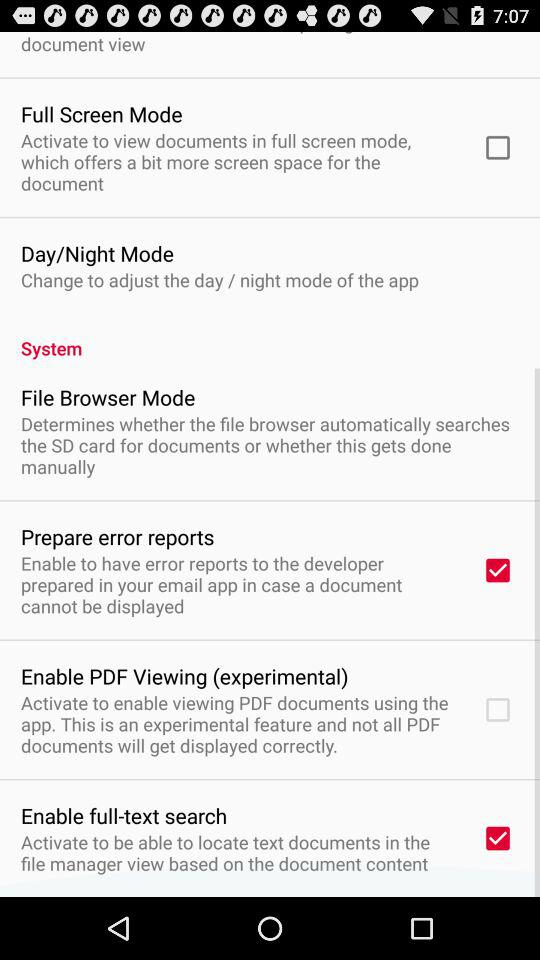What is the status of full screen mode? The status is off. 